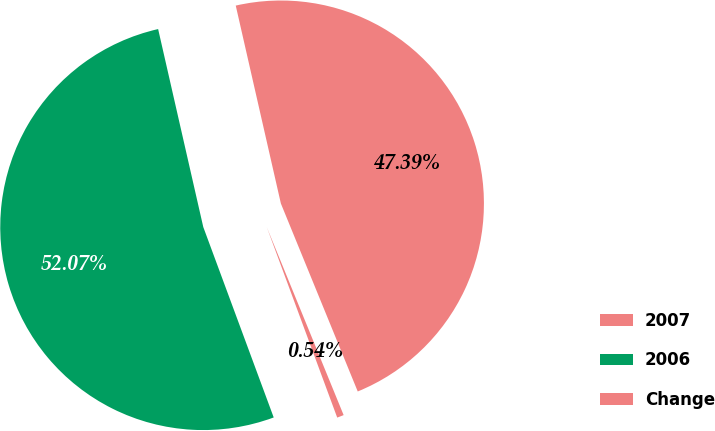Convert chart to OTSL. <chart><loc_0><loc_0><loc_500><loc_500><pie_chart><fcel>2007<fcel>2006<fcel>Change<nl><fcel>47.39%<fcel>52.07%<fcel>0.54%<nl></chart> 